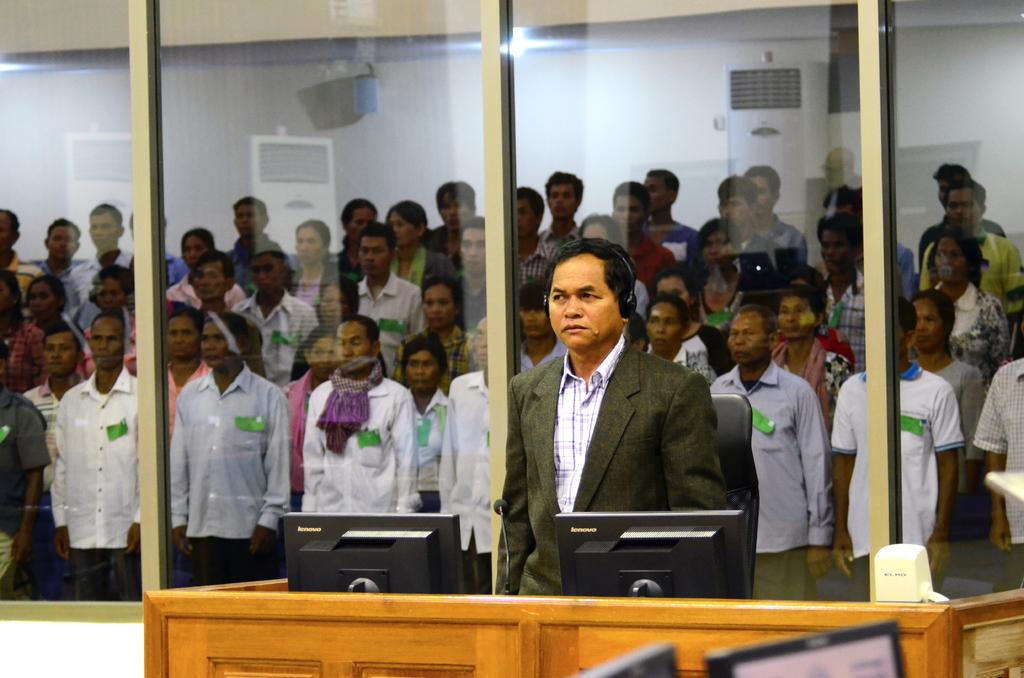How many monitors are visible in the image? There are four monitors in the image. What device is present for audio input in the image? There is a microphone (mike) in the image. What type of furniture is in the image? There is a chair in the image. What is the person in the image doing? There is a person standing in the image. Can you describe the background of the image? In the background of the image, there is a group of people standing, air coolers, and a wall. What type of cabbage is being weighed on the scale in the image? There is no scale or cabbage present in the image. How does the person's mind appear in the image? The person's mind is not visible in the image, as it is an abstract concept and not something that can be seen. 